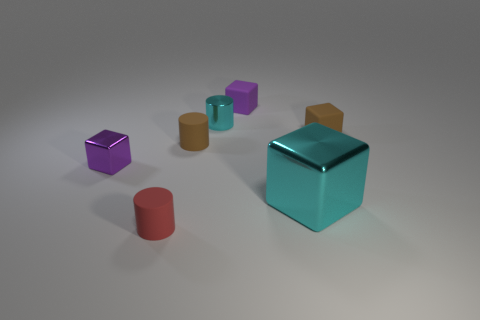Add 2 cyan cylinders. How many objects exist? 9 Subtract all blocks. How many objects are left? 3 Add 1 small metallic cylinders. How many small metallic cylinders are left? 2 Add 1 small blocks. How many small blocks exist? 4 Subtract 1 brown blocks. How many objects are left? 6 Subtract all big matte cylinders. Subtract all metallic objects. How many objects are left? 4 